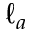<formula> <loc_0><loc_0><loc_500><loc_500>\ell _ { a }</formula> 